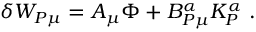<formula> <loc_0><loc_0><loc_500><loc_500>\delta W _ { P \mu } = A _ { \mu } \Phi + B _ { P \mu } ^ { \alpha } K _ { P } ^ { \alpha } \ .</formula> 